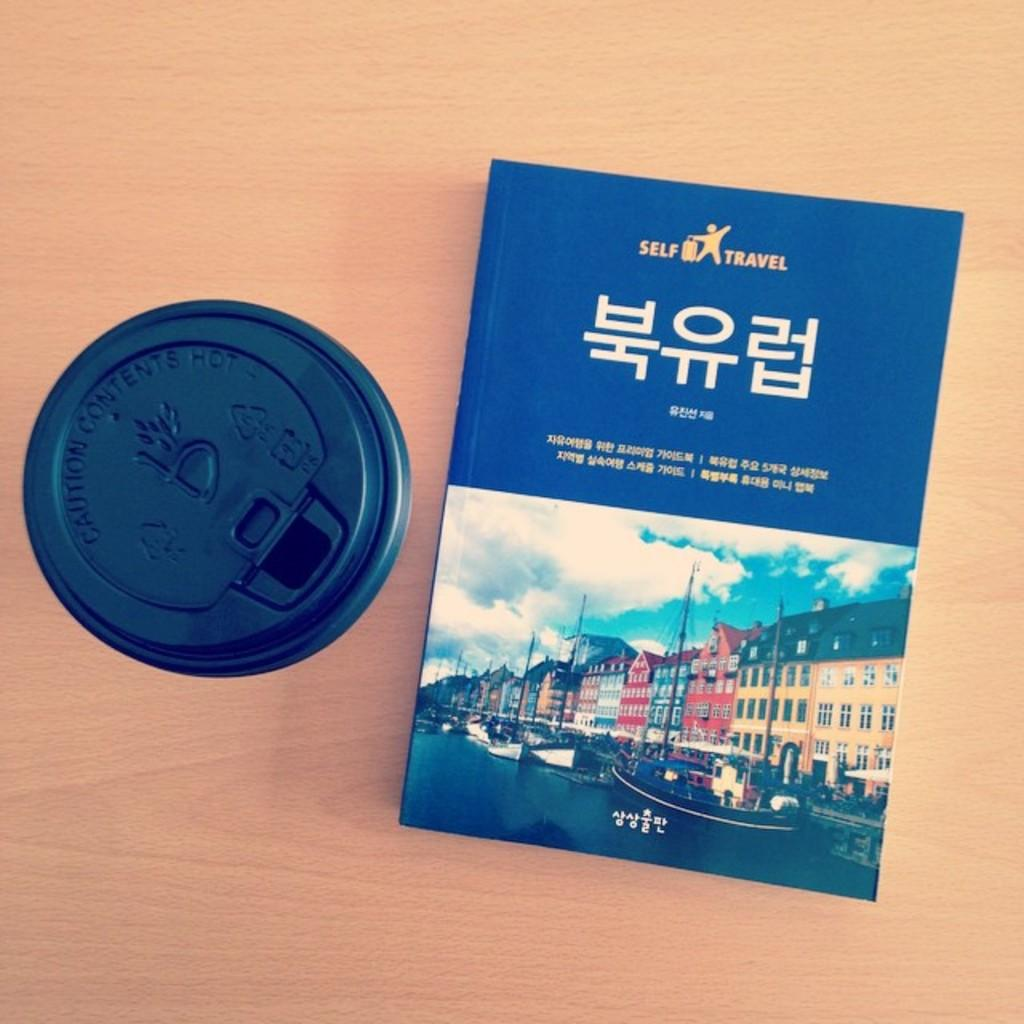<image>
Summarize the visual content of the image. A to-go cup of coffee sits next to a Self Travel book. 